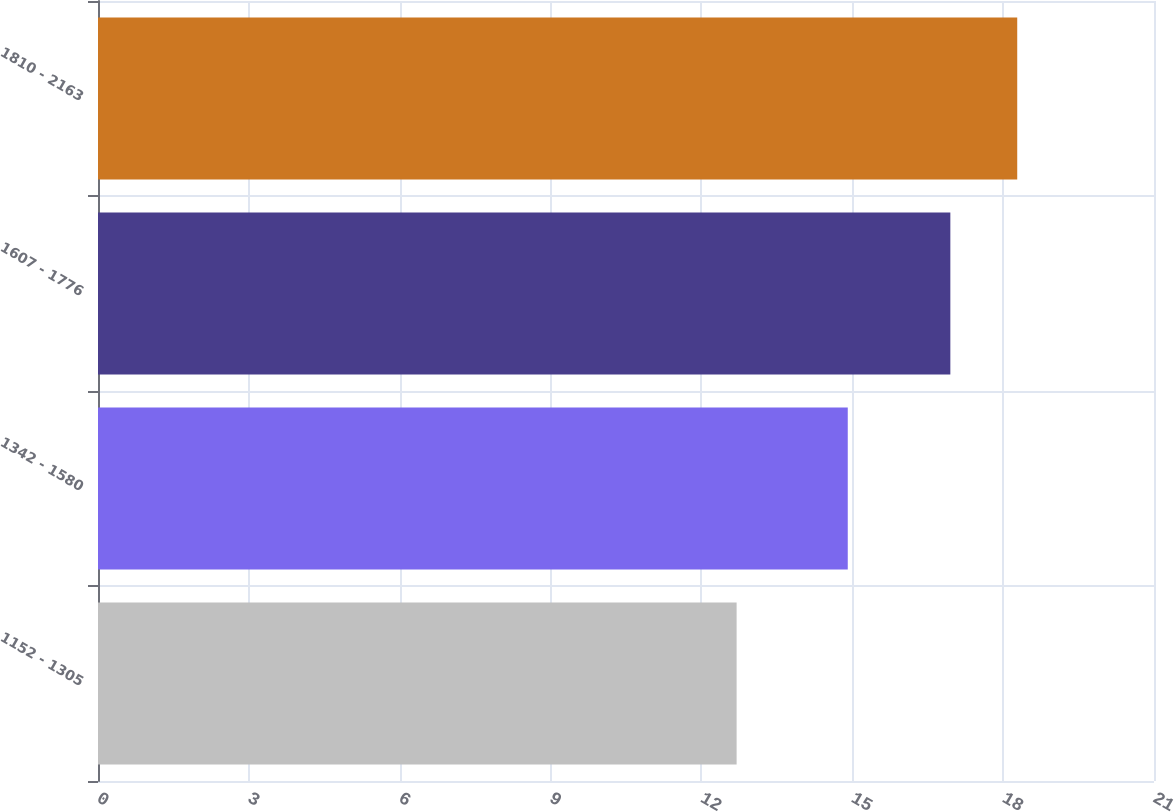Convert chart to OTSL. <chart><loc_0><loc_0><loc_500><loc_500><bar_chart><fcel>1152 - 1305<fcel>1342 - 1580<fcel>1607 - 1776<fcel>1810 - 2163<nl><fcel>12.7<fcel>14.91<fcel>16.95<fcel>18.28<nl></chart> 